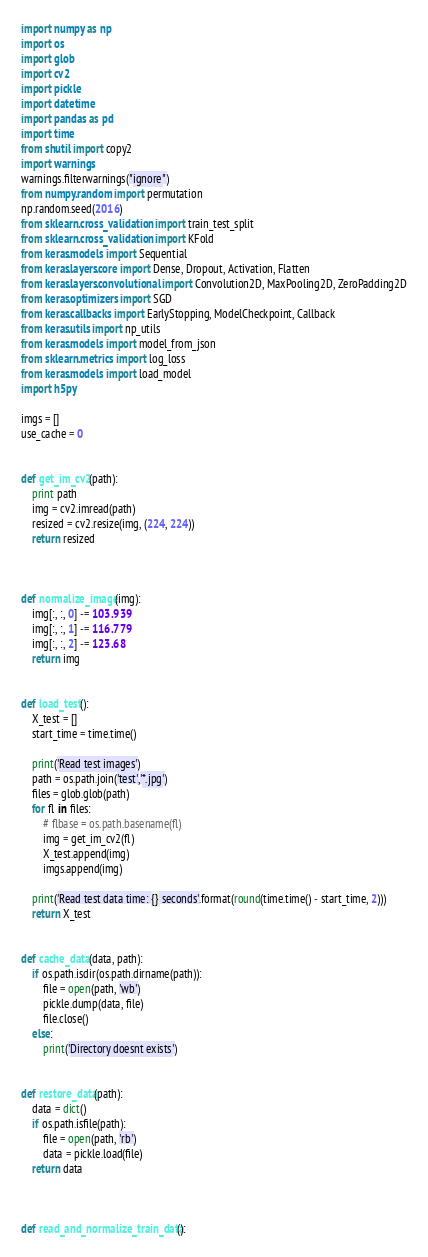Convert code to text. <code><loc_0><loc_0><loc_500><loc_500><_Python_>import numpy as np
import os
import glob
import cv2
import pickle
import datetime
import pandas as pd
import time
from shutil import copy2
import warnings
warnings.filterwarnings("ignore")
from numpy.random import permutation
np.random.seed(2016)
from sklearn.cross_validation import train_test_split
from sklearn.cross_validation import KFold
from keras.models import Sequential
from keras.layers.core import Dense, Dropout, Activation, Flatten
from keras.layers.convolutional import Convolution2D, MaxPooling2D, ZeroPadding2D
from keras.optimizers import SGD
from keras.callbacks import EarlyStopping, ModelCheckpoint, Callback
from keras.utils import np_utils
from keras.models import model_from_json
from sklearn.metrics import log_loss
from keras.models import load_model
import h5py

imgs = []
use_cache = 0


def get_im_cv2(path):
    print path
    img = cv2.imread(path)
    resized = cv2.resize(img, (224, 224))
    return resized



def normalize_image(img):
    img[:, :, 0] -= 103.939
    img[:, :, 1] -= 116.779
    img[:, :, 2] -= 123.68
    return img


def load_test():
    X_test = []
    start_time = time.time()

    print('Read test images')
    path = os.path.join('test','*.jpg')
    files = glob.glob(path)
    for fl in files:
        # flbase = os.path.basename(fl)
        img = get_im_cv2(fl)
        X_test.append(img)
        imgs.append(img)

    print('Read test data time: {} seconds'.format(round(time.time() - start_time, 2)))
    return X_test


def cache_data(data, path):
    if os.path.isdir(os.path.dirname(path)):
        file = open(path, 'wb')
        pickle.dump(data, file)
        file.close()
    else:
        print('Directory doesnt exists')


def restore_data(path):
    data = dict()
    if os.path.isfile(path):
        file = open(path, 'rb')
        data = pickle.load(file)
    return data



def read_and_normalize_train_data():</code> 